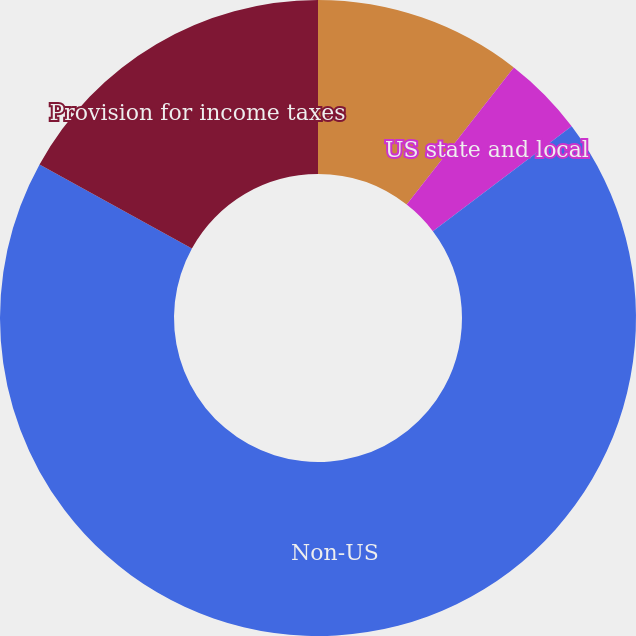<chart> <loc_0><loc_0><loc_500><loc_500><pie_chart><fcel>US federal<fcel>US state and local<fcel>Non-US<fcel>Provision for income taxes<nl><fcel>10.56%<fcel>4.14%<fcel>68.33%<fcel>16.98%<nl></chart> 